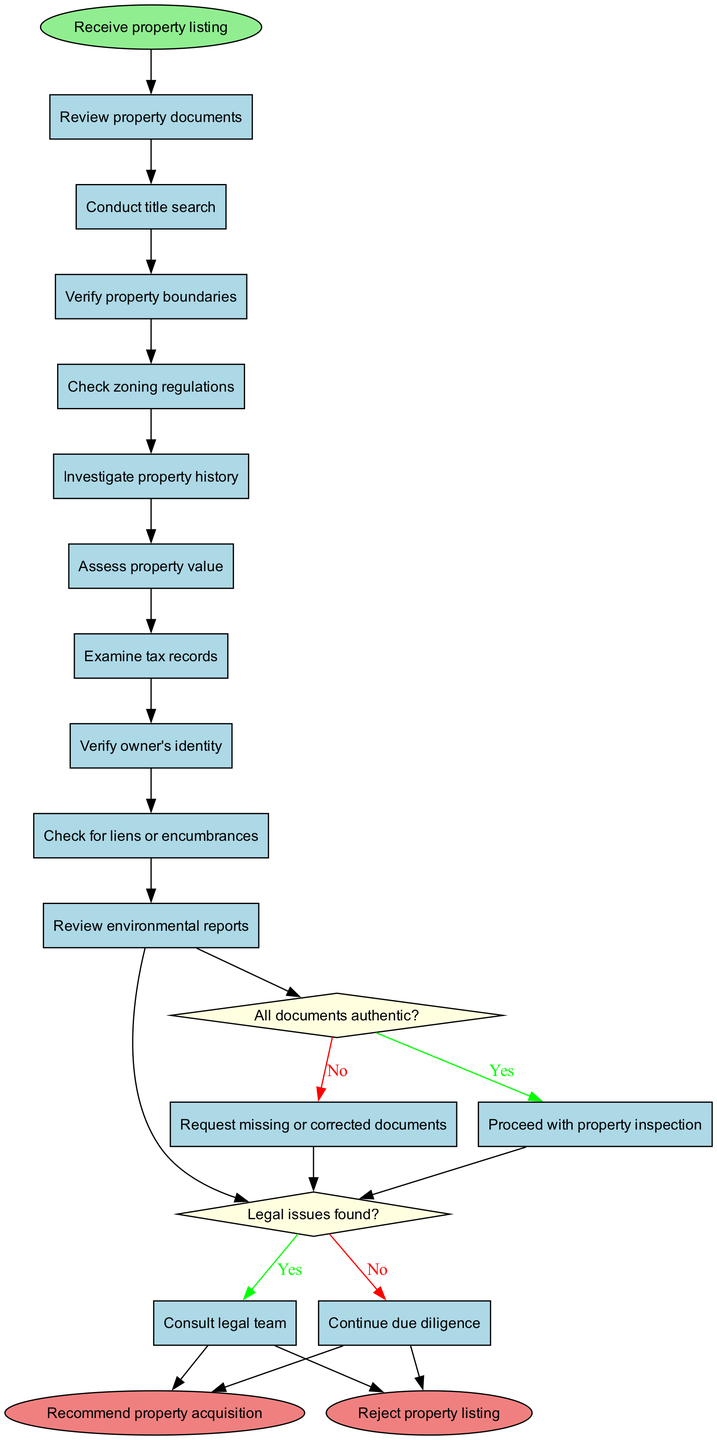What is the start node of the diagram? The start node of the diagram is labeled as "Receive property listing". This can be found at the top of the diagram, indicating where the process begins.
Answer: Receive property listing How many activities are included in the diagram? There are a total of 10 activities listed in the diagram. This can be counted by looking at the activities section provided.
Answer: 10 What is the last activity before the first decision point? The last activity before the first decision point is "Review environmental reports". This is the last activity listed before reaching the decision node in the flow of the diagram.
Answer: Review environmental reports What decision follows the act of verifying property boundaries? Following the act of verifying property boundaries, the decision "All documents authentic?" is made. This decision is linked to the last activity and is the next step in the process.
Answer: All documents authentic? If all documents are authentic, what is the next step? If all documents are authentic, the next step is "Proceed with property inspection". This means that the process continues towards property inspection if there are no issues with the authenticity of the documents.
Answer: Proceed with property inspection How many end nodes are present in the diagram? The diagram contains 2 end nodes, which are "Recommend property acquisition" and "Reject property listing". This can be observed at the conclusion of the decision flow.
Answer: 2 What happens if legal issues are found during the due diligence? If legal issues are found during the due diligence process, the next step is to "Consult legal team". This is defined in the decision-making flow of the diagram based on the possible outcome of finding legal issues.
Answer: Consult legal team What is the shape of decision nodes in the diagram? The decision nodes in the diagram are shaped like diamonds. This is a characteristic feature of decision nodes in activity diagrams, indicating points where choices are made.
Answer: Diamond What is the color of the start node? The start node is colored light green. This color distinguishes the start node from other nodes in the diagram and highlights it as the entry point.
Answer: Light green 